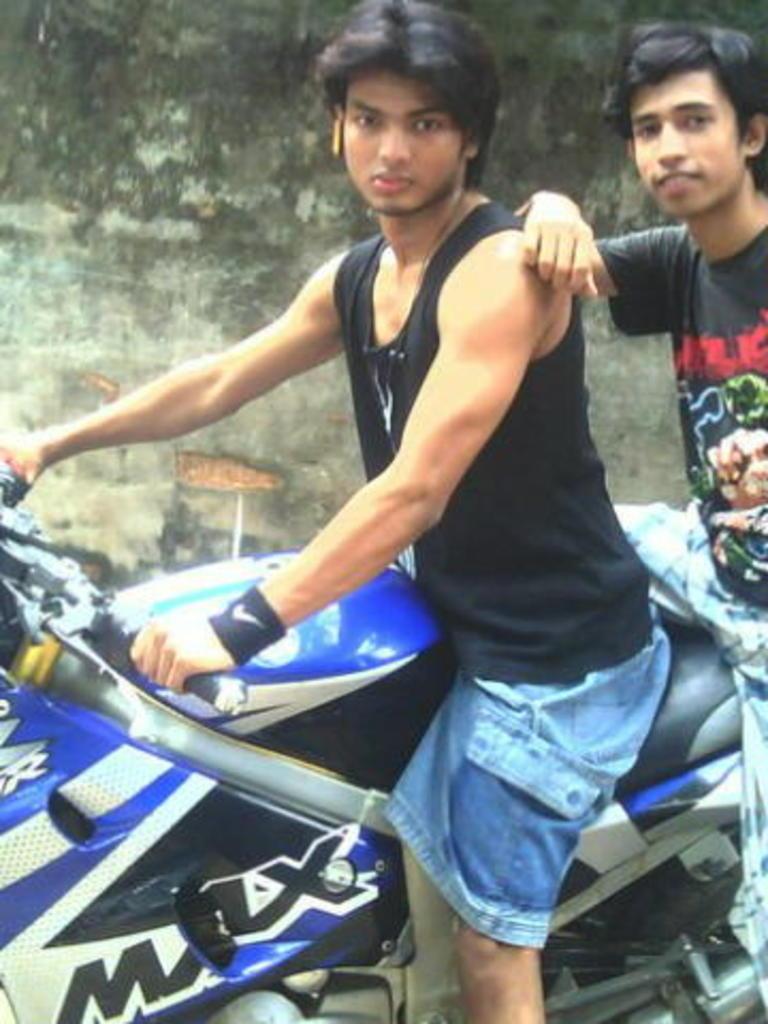How would you summarize this image in a sentence or two? This image is clicked outside. There is a bike in the bottom which is in blue color. There are 2 persons sitting on that bike, both of them are wearing black t shirt. One of them is wearing jeans short. And the other one is wearing light colored pant. Back side of them there is a wall. 